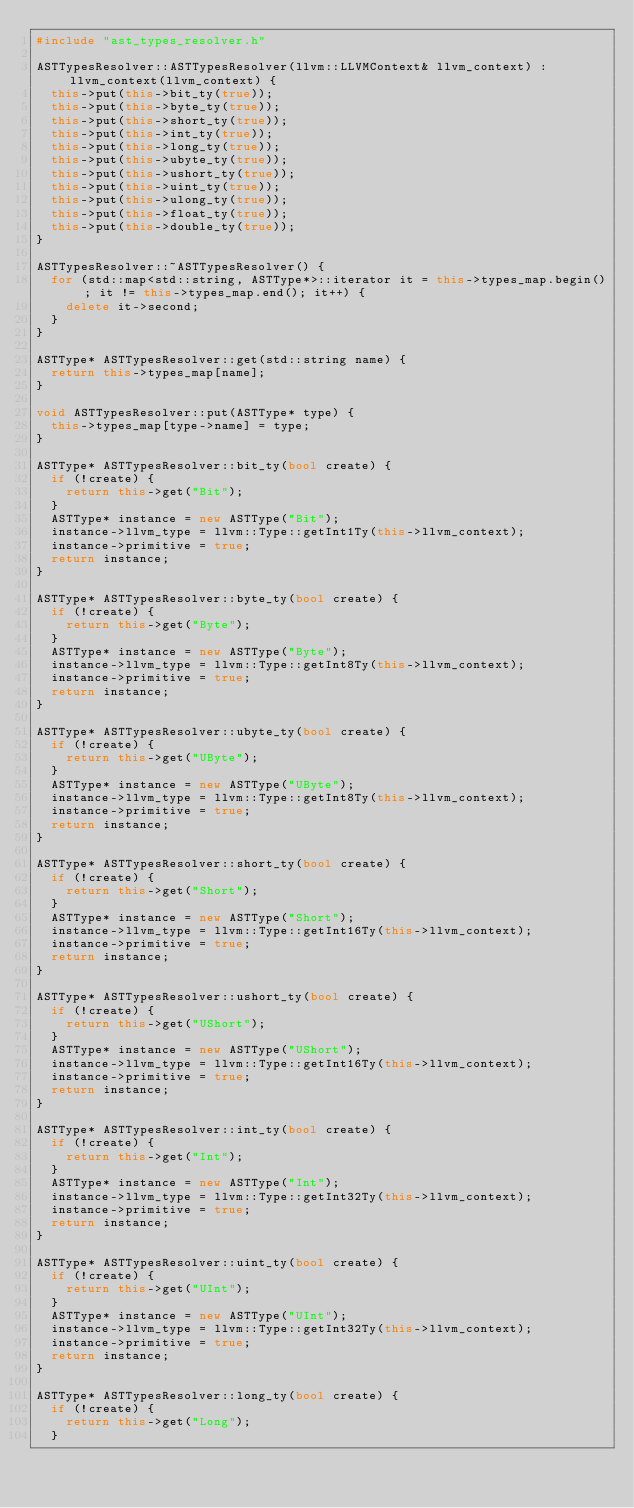Convert code to text. <code><loc_0><loc_0><loc_500><loc_500><_C++_>#include "ast_types_resolver.h"

ASTTypesResolver::ASTTypesResolver(llvm::LLVMContext& llvm_context) : llvm_context(llvm_context) {
	this->put(this->bit_ty(true));
	this->put(this->byte_ty(true));
	this->put(this->short_ty(true));
	this->put(this->int_ty(true));
	this->put(this->long_ty(true));
	this->put(this->ubyte_ty(true));
	this->put(this->ushort_ty(true));
	this->put(this->uint_ty(true));
	this->put(this->ulong_ty(true));
	this->put(this->float_ty(true));
	this->put(this->double_ty(true));
}

ASTTypesResolver::~ASTTypesResolver() {
	for (std::map<std::string, ASTType*>::iterator it = this->types_map.begin(); it != this->types_map.end(); it++) {
		delete it->second;
	}
}

ASTType* ASTTypesResolver::get(std::string name) {
	return this->types_map[name];
}

void ASTTypesResolver::put(ASTType* type) {
	this->types_map[type->name] = type;
}

ASTType* ASTTypesResolver::bit_ty(bool create) {
	if (!create) {
		return this->get("Bit");
	}
	ASTType* instance = new ASTType("Bit");
	instance->llvm_type = llvm::Type::getInt1Ty(this->llvm_context);
	instance->primitive = true;
	return instance;
}

ASTType* ASTTypesResolver::byte_ty(bool create) {
	if (!create) {
		return this->get("Byte");
	}
	ASTType* instance = new ASTType("Byte");
	instance->llvm_type = llvm::Type::getInt8Ty(this->llvm_context);
	instance->primitive = true;
	return instance;
}

ASTType* ASTTypesResolver::ubyte_ty(bool create) {
	if (!create) {
		return this->get("UByte");
	}
	ASTType* instance = new ASTType("UByte");
	instance->llvm_type = llvm::Type::getInt8Ty(this->llvm_context);
	instance->primitive = true;
	return instance;
}

ASTType* ASTTypesResolver::short_ty(bool create) {
	if (!create) {
		return this->get("Short");
	}
	ASTType* instance = new ASTType("Short");
	instance->llvm_type = llvm::Type::getInt16Ty(this->llvm_context);
	instance->primitive = true;
	return instance;
}

ASTType* ASTTypesResolver::ushort_ty(bool create) {
	if (!create) {
		return this->get("UShort");
	}
	ASTType* instance = new ASTType("UShort");
	instance->llvm_type = llvm::Type::getInt16Ty(this->llvm_context);
	instance->primitive = true;
	return instance;
}

ASTType* ASTTypesResolver::int_ty(bool create) {
	if (!create) {
		return this->get("Int");
	}
	ASTType* instance = new ASTType("Int");
	instance->llvm_type = llvm::Type::getInt32Ty(this->llvm_context);
	instance->primitive = true;
	return instance;
}

ASTType* ASTTypesResolver::uint_ty(bool create) {
	if (!create) {
		return this->get("UInt");
	}
	ASTType* instance = new ASTType("UInt");
	instance->llvm_type = llvm::Type::getInt32Ty(this->llvm_context);
	instance->primitive = true;
	return instance;
}

ASTType* ASTTypesResolver::long_ty(bool create) {
	if (!create) {
		return this->get("Long");
	}</code> 